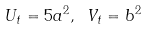Convert formula to latex. <formula><loc_0><loc_0><loc_500><loc_500>U _ { t } = 5 a ^ { 2 } , \text { } V _ { t } = b ^ { 2 }</formula> 